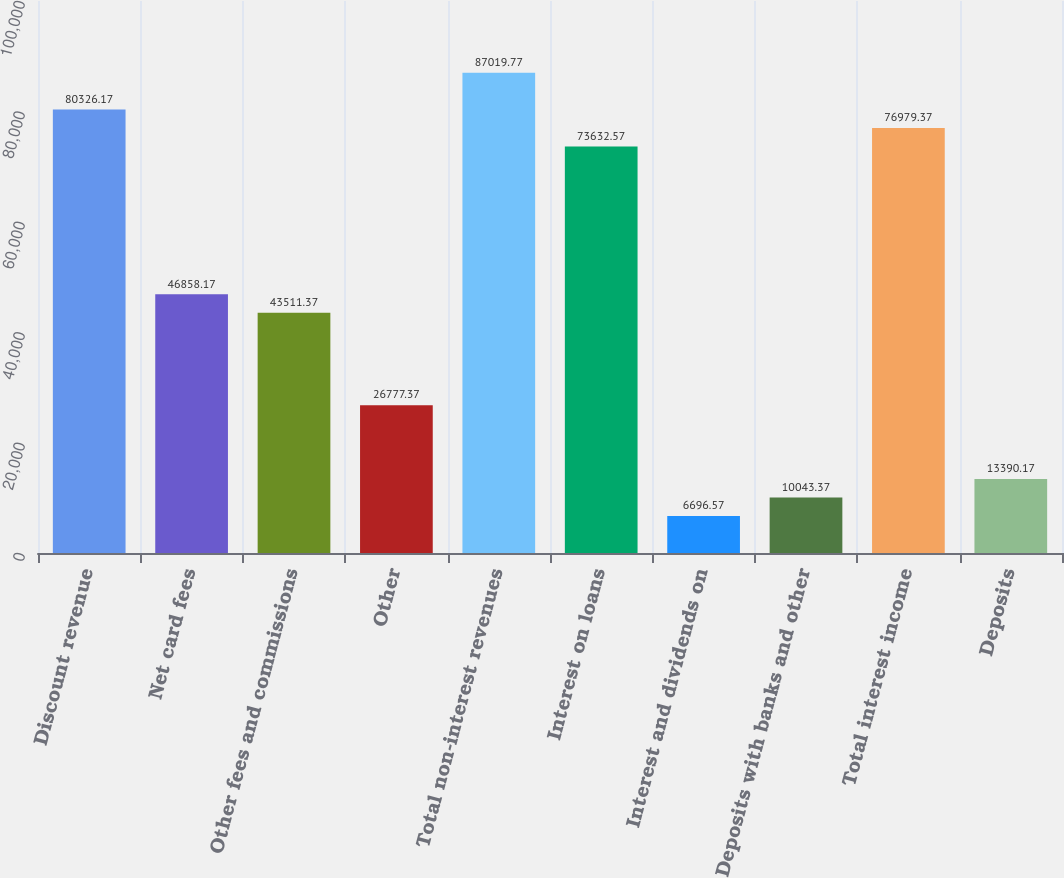<chart> <loc_0><loc_0><loc_500><loc_500><bar_chart><fcel>Discount revenue<fcel>Net card fees<fcel>Other fees and commissions<fcel>Other<fcel>Total non-interest revenues<fcel>Interest on loans<fcel>Interest and dividends on<fcel>Deposits with banks and other<fcel>Total interest income<fcel>Deposits<nl><fcel>80326.2<fcel>46858.2<fcel>43511.4<fcel>26777.4<fcel>87019.8<fcel>73632.6<fcel>6696.57<fcel>10043.4<fcel>76979.4<fcel>13390.2<nl></chart> 